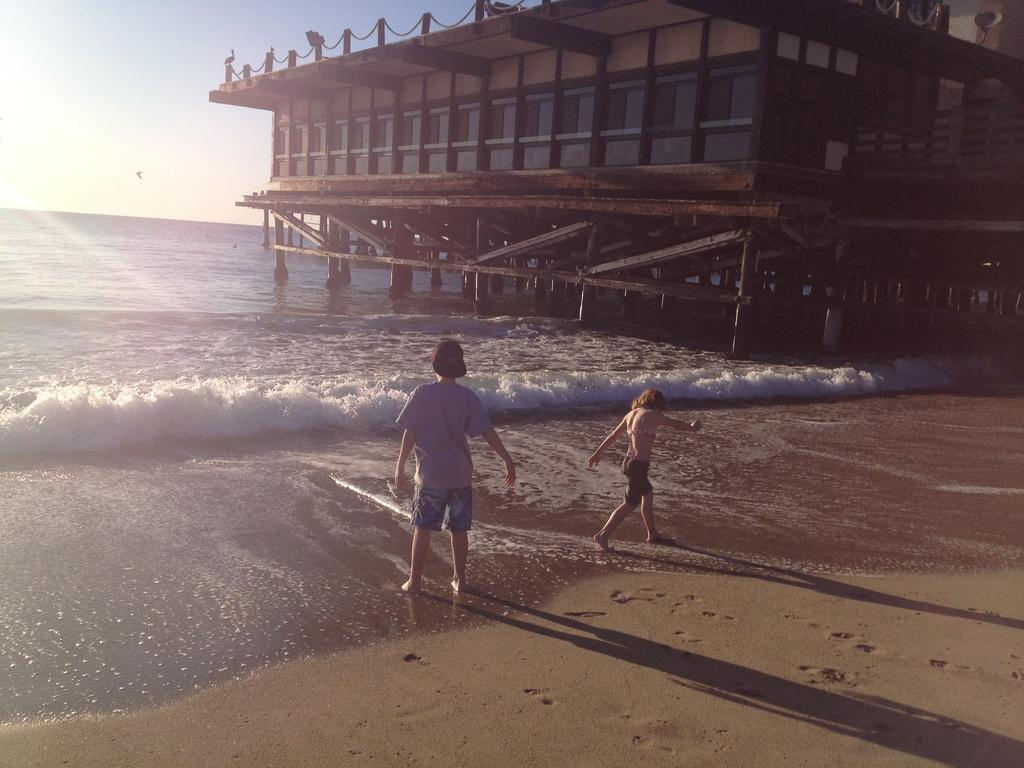How many people are present in the image? There are two persons standing on the seashore. What can be seen in the background of the image? There is a wooden house, water, and the sky visible in the background. What color are the crayons being used by the geese in the image? There are no geese or crayons present in the image. 